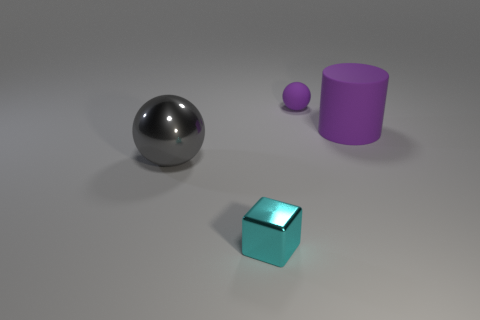How would you use these objects to explain the concept of geometry to a child? These objects can serve as a hands-on lesson in geometry. The metal ball is a great example of a sphere, which has a perfectly round shape. The cube is a representation of a square in three dimensions, showing six equal squares as its faces. Lastly, the cylinder demonstrates a shape with a circular base and parallel sides, perfect for a child to visualize geometrical forms in three-dimensional space. 